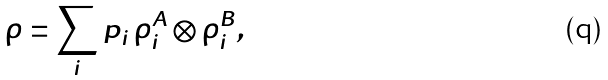<formula> <loc_0><loc_0><loc_500><loc_500>\rho = \sum _ { i } p _ { i } \, \rho ^ { A } _ { i } \otimes \rho ^ { B } _ { i } ,</formula> 